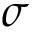<formula> <loc_0><loc_0><loc_500><loc_500>\sigma</formula> 